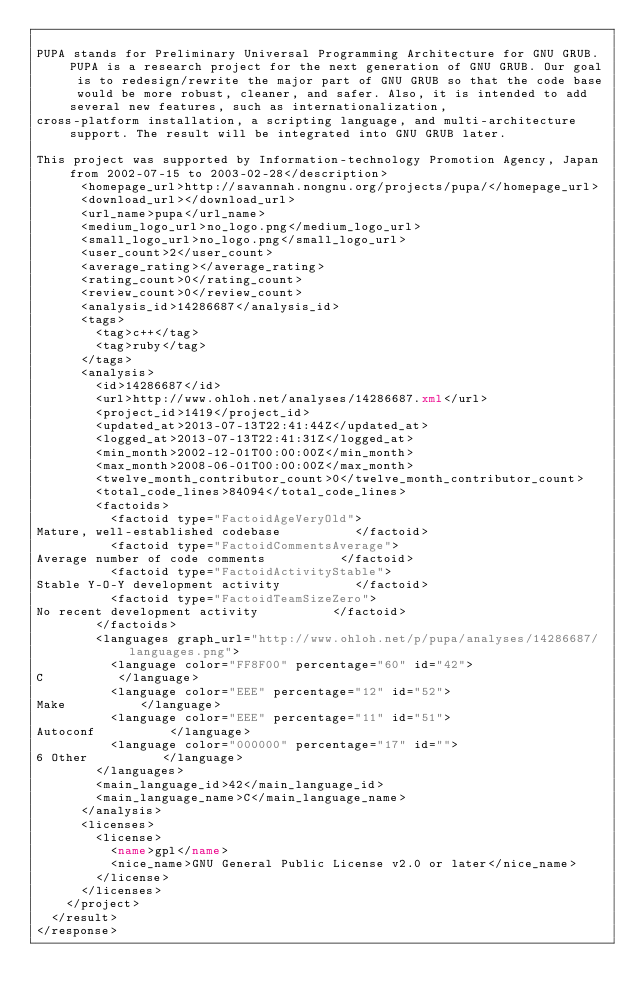Convert code to text. <code><loc_0><loc_0><loc_500><loc_500><_XML_>
PUPA stands for Preliminary Universal Programming Architecture for GNU GRUB. PUPA is a research project for the next generation of GNU GRUB. Our goal is to redesign/rewrite the major part of GNU GRUB so that the code base would be more robust, cleaner, and safer. Also, it is intended to add several new features, such as internationalization,
cross-platform installation, a scripting language, and multi-architecture support. The result will be integrated into GNU GRUB later.

This project was supported by Information-technology Promotion Agency, Japan from 2002-07-15 to 2003-02-28</description>
      <homepage_url>http://savannah.nongnu.org/projects/pupa/</homepage_url>
      <download_url></download_url>
      <url_name>pupa</url_name>
      <medium_logo_url>no_logo.png</medium_logo_url>
      <small_logo_url>no_logo.png</small_logo_url>
      <user_count>2</user_count>
      <average_rating></average_rating>
      <rating_count>0</rating_count>
      <review_count>0</review_count>
      <analysis_id>14286687</analysis_id>
      <tags>
        <tag>c++</tag>
        <tag>ruby</tag>
      </tags>
      <analysis>
        <id>14286687</id>
        <url>http://www.ohloh.net/analyses/14286687.xml</url>
        <project_id>1419</project_id>
        <updated_at>2013-07-13T22:41:44Z</updated_at>
        <logged_at>2013-07-13T22:41:31Z</logged_at>
        <min_month>2002-12-01T00:00:00Z</min_month>
        <max_month>2008-06-01T00:00:00Z</max_month>
        <twelve_month_contributor_count>0</twelve_month_contributor_count>
        <total_code_lines>84094</total_code_lines>
        <factoids>
          <factoid type="FactoidAgeVeryOld">
Mature, well-established codebase          </factoid>
          <factoid type="FactoidCommentsAverage">
Average number of code comments          </factoid>
          <factoid type="FactoidActivityStable">
Stable Y-O-Y development activity          </factoid>
          <factoid type="FactoidTeamSizeZero">
No recent development activity          </factoid>
        </factoids>
        <languages graph_url="http://www.ohloh.net/p/pupa/analyses/14286687/languages.png">
          <language color="FF8F00" percentage="60" id="42">
C          </language>
          <language color="EEE" percentage="12" id="52">
Make          </language>
          <language color="EEE" percentage="11" id="51">
Autoconf          </language>
          <language color="000000" percentage="17" id="">
6 Other          </language>
        </languages>
        <main_language_id>42</main_language_id>
        <main_language_name>C</main_language_name>
      </analysis>
      <licenses>
        <license>
          <name>gpl</name>
          <nice_name>GNU General Public License v2.0 or later</nice_name>
        </license>
      </licenses>
    </project>
  </result>
</response>
</code> 